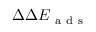Convert formula to latex. <formula><loc_0><loc_0><loc_500><loc_500>\Delta \Delta E _ { a d s }</formula> 